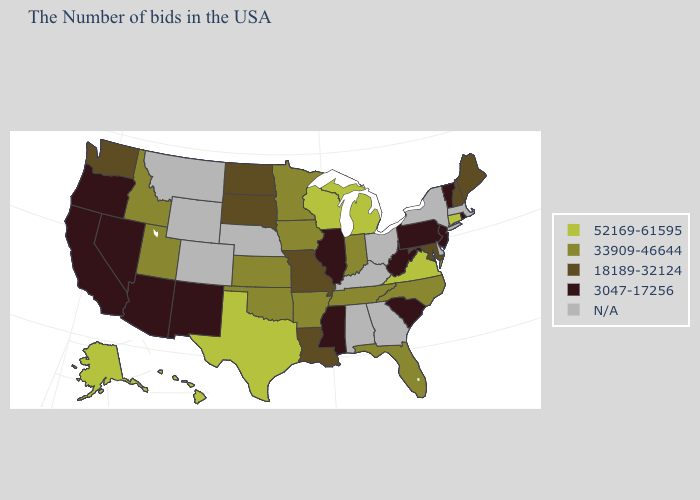Name the states that have a value in the range 3047-17256?
Write a very short answer. Rhode Island, Vermont, New Jersey, Pennsylvania, South Carolina, West Virginia, Illinois, Mississippi, New Mexico, Arizona, Nevada, California, Oregon. Name the states that have a value in the range 18189-32124?
Short answer required. Maine, New Hampshire, Maryland, Louisiana, Missouri, South Dakota, North Dakota, Washington. Does the first symbol in the legend represent the smallest category?
Give a very brief answer. No. Among the states that border Missouri , does Illinois have the lowest value?
Be succinct. Yes. What is the highest value in the USA?
Quick response, please. 52169-61595. How many symbols are there in the legend?
Be succinct. 5. What is the value of West Virginia?
Write a very short answer. 3047-17256. Among the states that border Arizona , does Utah have the highest value?
Give a very brief answer. Yes. What is the lowest value in states that border Colorado?
Answer briefly. 3047-17256. What is the value of Alabama?
Quick response, please. N/A. Does Washington have the highest value in the USA?
Give a very brief answer. No. Does the map have missing data?
Be succinct. Yes. Name the states that have a value in the range 18189-32124?
Write a very short answer. Maine, New Hampshire, Maryland, Louisiana, Missouri, South Dakota, North Dakota, Washington. Does the first symbol in the legend represent the smallest category?
Concise answer only. No. Which states hav the highest value in the Northeast?
Keep it brief. Connecticut. 